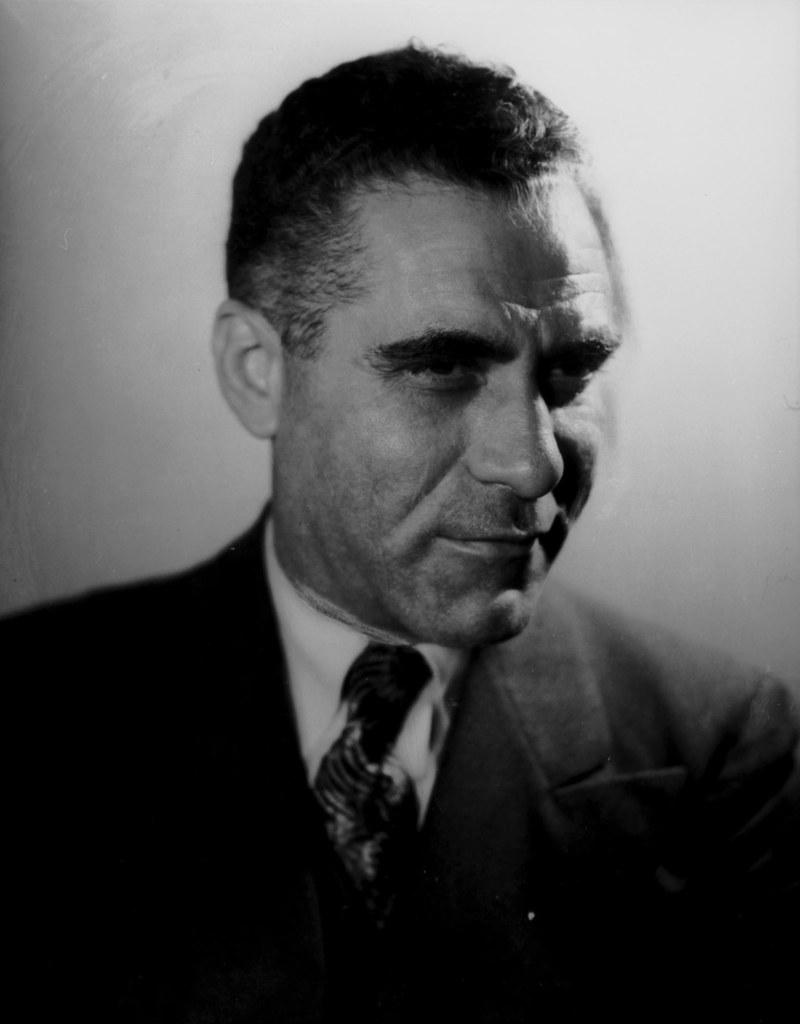What type of picture is in the image? The image contains a black and white picture of a person. What color is the background of the picture? The background of the picture is white. What type of quiver is visible in the image? There is no quiver present in the image. What type of destruction can be seen happening in the image? There is no destruction present in the image. 